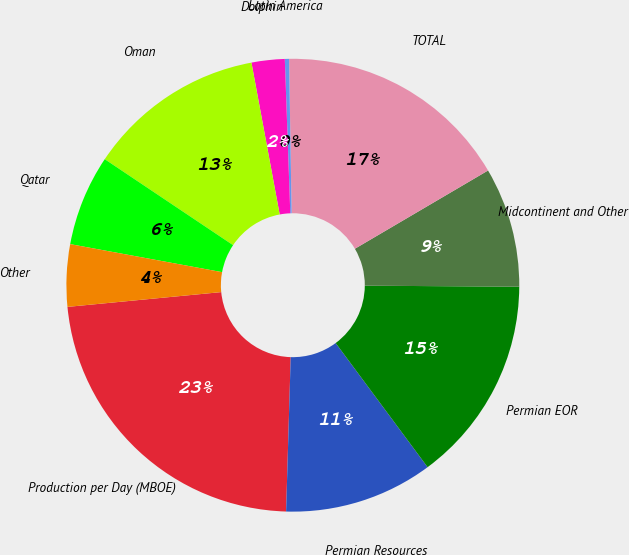Convert chart to OTSL. <chart><loc_0><loc_0><loc_500><loc_500><pie_chart><fcel>Production per Day (MBOE)<fcel>Permian Resources<fcel>Permian EOR<fcel>Midcontinent and Other<fcel>TOTAL<fcel>Latin America<fcel>Dolphin<fcel>Oman<fcel>Qatar<fcel>Other<nl><fcel>23.0%<fcel>10.62%<fcel>14.75%<fcel>8.56%<fcel>16.81%<fcel>0.3%<fcel>2.36%<fcel>12.68%<fcel>6.49%<fcel>4.43%<nl></chart> 